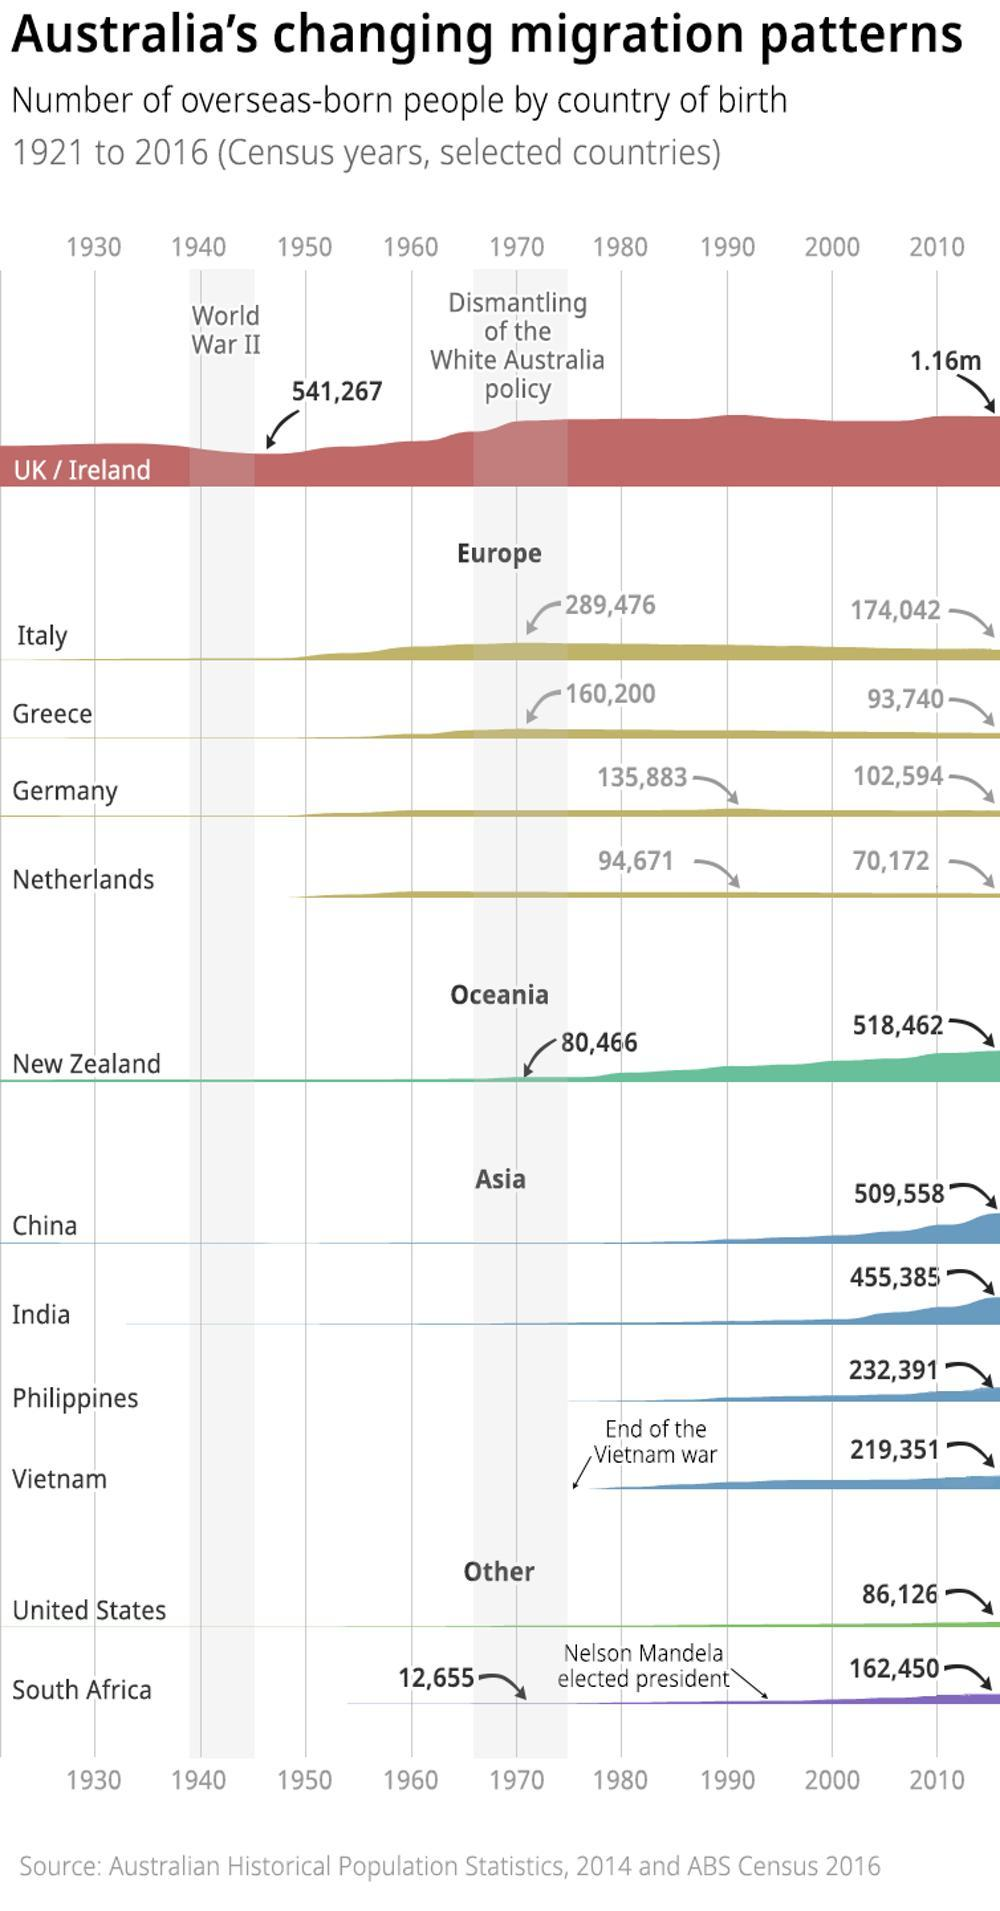which is the second lowest population from Asia
Answer the question with a short phrase. Philippines which country from Europe has shown the highest dip in  numbers after 1970 Italy How many years after world war II was the dismantling of the white australia policy 30 